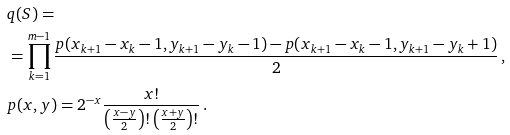Convert formula to latex. <formula><loc_0><loc_0><loc_500><loc_500>& q ( S ) = \\ & = \prod _ { k = 1 } ^ { m - 1 } \frac { p ( x _ { k + 1 } - x _ { k } - 1 , y _ { k + 1 } - y _ { k } - 1 ) - p ( x _ { k + 1 } - x _ { k } - 1 , y _ { k + 1 } - y _ { k } + 1 ) } { 2 } \, , \\ & p ( x , y ) = 2 ^ { - x } \frac { x ! } { \left ( \frac { x - y } 2 \right ) ! \left ( \frac { x + y } 2 \right ) ! } \, .</formula> 